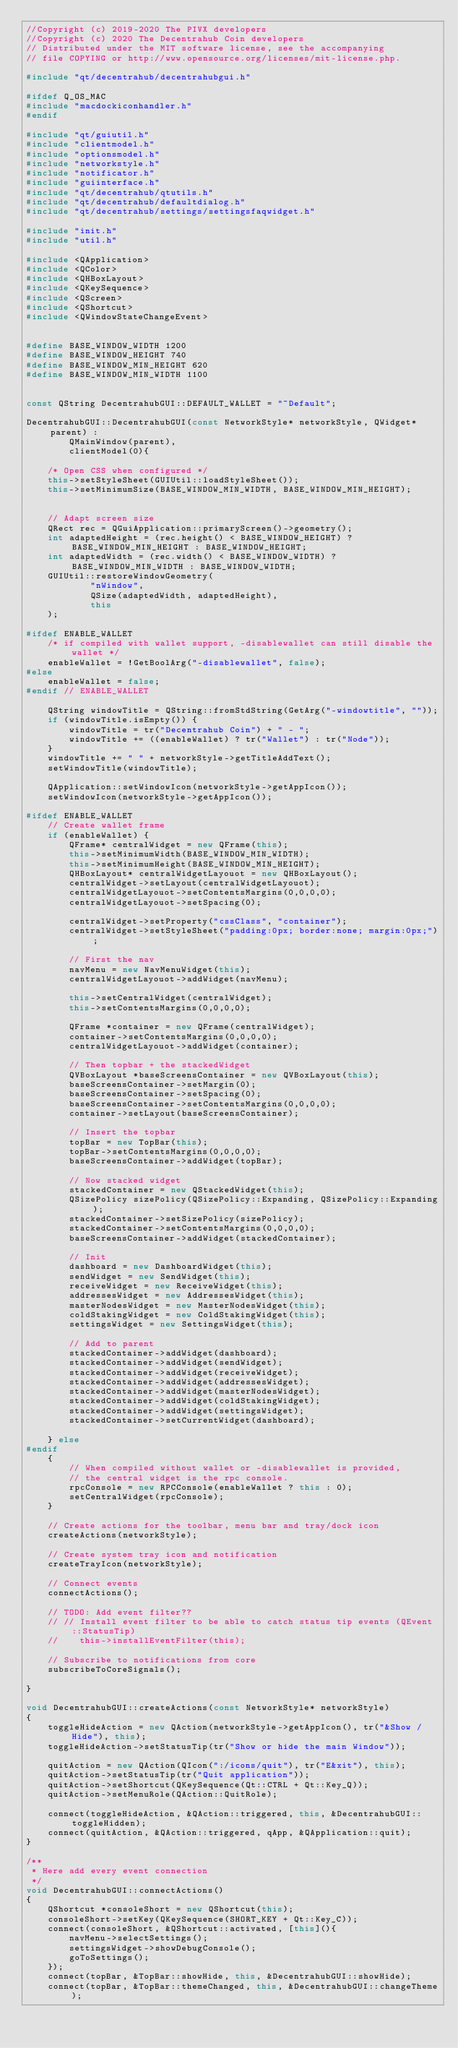<code> <loc_0><loc_0><loc_500><loc_500><_C++_>//Copyright (c) 2019-2020 The PIVX developers
//Copyright (c) 2020 The Decentrahub Coin developers
// Distributed under the MIT software license, see the accompanying
// file COPYING or http://www.opensource.org/licenses/mit-license.php.

#include "qt/decentrahub/decentrahubgui.h"

#ifdef Q_OS_MAC
#include "macdockiconhandler.h"
#endif

#include "qt/guiutil.h"
#include "clientmodel.h"
#include "optionsmodel.h"
#include "networkstyle.h"
#include "notificator.h"
#include "guiinterface.h"
#include "qt/decentrahub/qtutils.h"
#include "qt/decentrahub/defaultdialog.h"
#include "qt/decentrahub/settings/settingsfaqwidget.h"

#include "init.h"
#include "util.h"

#include <QApplication>
#include <QColor>
#include <QHBoxLayout>
#include <QKeySequence>
#include <QScreen>
#include <QShortcut>
#include <QWindowStateChangeEvent>


#define BASE_WINDOW_WIDTH 1200
#define BASE_WINDOW_HEIGHT 740
#define BASE_WINDOW_MIN_HEIGHT 620
#define BASE_WINDOW_MIN_WIDTH 1100


const QString DecentrahubGUI::DEFAULT_WALLET = "~Default";

DecentrahubGUI::DecentrahubGUI(const NetworkStyle* networkStyle, QWidget* parent) :
        QMainWindow(parent),
        clientModel(0){

    /* Open CSS when configured */
    this->setStyleSheet(GUIUtil::loadStyleSheet());
    this->setMinimumSize(BASE_WINDOW_MIN_WIDTH, BASE_WINDOW_MIN_HEIGHT);


    // Adapt screen size
	QRect rec = QGuiApplication::primaryScreen()->geometry();
    int adaptedHeight = (rec.height() < BASE_WINDOW_HEIGHT) ?  BASE_WINDOW_MIN_HEIGHT : BASE_WINDOW_HEIGHT;
    int adaptedWidth = (rec.width() < BASE_WINDOW_WIDTH) ?  BASE_WINDOW_MIN_WIDTH : BASE_WINDOW_WIDTH;
    GUIUtil::restoreWindowGeometry(
            "nWindow",
            QSize(adaptedWidth, adaptedHeight),
            this
    );

#ifdef ENABLE_WALLET
    /* if compiled with wallet support, -disablewallet can still disable the wallet */
    enableWallet = !GetBoolArg("-disablewallet", false);
#else
    enableWallet = false;
#endif // ENABLE_WALLET

    QString windowTitle = QString::fromStdString(GetArg("-windowtitle", ""));
    if (windowTitle.isEmpty()) {
        windowTitle = tr("Decentrahub Coin") + " - ";
        windowTitle += ((enableWallet) ? tr("Wallet") : tr("Node"));
    }
    windowTitle += " " + networkStyle->getTitleAddText();
    setWindowTitle(windowTitle);

    QApplication::setWindowIcon(networkStyle->getAppIcon());
    setWindowIcon(networkStyle->getAppIcon());

#ifdef ENABLE_WALLET
    // Create wallet frame
    if (enableWallet) {
        QFrame* centralWidget = new QFrame(this);
        this->setMinimumWidth(BASE_WINDOW_MIN_WIDTH);
        this->setMinimumHeight(BASE_WINDOW_MIN_HEIGHT);
        QHBoxLayout* centralWidgetLayouot = new QHBoxLayout();
        centralWidget->setLayout(centralWidgetLayouot);
        centralWidgetLayouot->setContentsMargins(0,0,0,0);
        centralWidgetLayouot->setSpacing(0);

        centralWidget->setProperty("cssClass", "container");
        centralWidget->setStyleSheet("padding:0px; border:none; margin:0px;");

        // First the nav
        navMenu = new NavMenuWidget(this);
        centralWidgetLayouot->addWidget(navMenu);

        this->setCentralWidget(centralWidget);
        this->setContentsMargins(0,0,0,0);

        QFrame *container = new QFrame(centralWidget);
        container->setContentsMargins(0,0,0,0);
        centralWidgetLayouot->addWidget(container);

        // Then topbar + the stackedWidget
        QVBoxLayout *baseScreensContainer = new QVBoxLayout(this);
        baseScreensContainer->setMargin(0);
        baseScreensContainer->setSpacing(0);
        baseScreensContainer->setContentsMargins(0,0,0,0);
        container->setLayout(baseScreensContainer);

        // Insert the topbar
        topBar = new TopBar(this);
        topBar->setContentsMargins(0,0,0,0);
        baseScreensContainer->addWidget(topBar);

        // Now stacked widget
        stackedContainer = new QStackedWidget(this);
        QSizePolicy sizePolicy(QSizePolicy::Expanding, QSizePolicy::Expanding);
        stackedContainer->setSizePolicy(sizePolicy);
        stackedContainer->setContentsMargins(0,0,0,0);
        baseScreensContainer->addWidget(stackedContainer);

        // Init
        dashboard = new DashboardWidget(this);
        sendWidget = new SendWidget(this);
        receiveWidget = new ReceiveWidget(this);
        addressesWidget = new AddressesWidget(this);
        masterNodesWidget = new MasterNodesWidget(this);
        coldStakingWidget = new ColdStakingWidget(this);
        settingsWidget = new SettingsWidget(this);

        // Add to parent
        stackedContainer->addWidget(dashboard);
        stackedContainer->addWidget(sendWidget);
        stackedContainer->addWidget(receiveWidget);
        stackedContainer->addWidget(addressesWidget);
        stackedContainer->addWidget(masterNodesWidget);
        stackedContainer->addWidget(coldStakingWidget);
        stackedContainer->addWidget(settingsWidget);
        stackedContainer->setCurrentWidget(dashboard);

    } else
#endif
    {
        // When compiled without wallet or -disablewallet is provided,
        // the central widget is the rpc console.
        rpcConsole = new RPCConsole(enableWallet ? this : 0);
        setCentralWidget(rpcConsole);
    }

    // Create actions for the toolbar, menu bar and tray/dock icon
    createActions(networkStyle);

    // Create system tray icon and notification
    createTrayIcon(networkStyle);

    // Connect events
    connectActions();

    // TODO: Add event filter??
    // // Install event filter to be able to catch status tip events (QEvent::StatusTip)
    //    this->installEventFilter(this);

    // Subscribe to notifications from core
    subscribeToCoreSignals();

}

void DecentrahubGUI::createActions(const NetworkStyle* networkStyle)
{
    toggleHideAction = new QAction(networkStyle->getAppIcon(), tr("&Show / Hide"), this);
    toggleHideAction->setStatusTip(tr("Show or hide the main Window"));

    quitAction = new QAction(QIcon(":/icons/quit"), tr("E&xit"), this);
    quitAction->setStatusTip(tr("Quit application"));
    quitAction->setShortcut(QKeySequence(Qt::CTRL + Qt::Key_Q));
    quitAction->setMenuRole(QAction::QuitRole);

    connect(toggleHideAction, &QAction::triggered, this, &DecentrahubGUI::toggleHidden);
    connect(quitAction, &QAction::triggered, qApp, &QApplication::quit);
}

/**
 * Here add every event connection
 */
void DecentrahubGUI::connectActions()
{
    QShortcut *consoleShort = new QShortcut(this);
    consoleShort->setKey(QKeySequence(SHORT_KEY + Qt::Key_C));
    connect(consoleShort, &QShortcut::activated, [this](){
        navMenu->selectSettings();
        settingsWidget->showDebugConsole();
        goToSettings();
    });
    connect(topBar, &TopBar::showHide, this, &DecentrahubGUI::showHide);
    connect(topBar, &TopBar::themeChanged, this, &DecentrahubGUI::changeTheme);</code> 